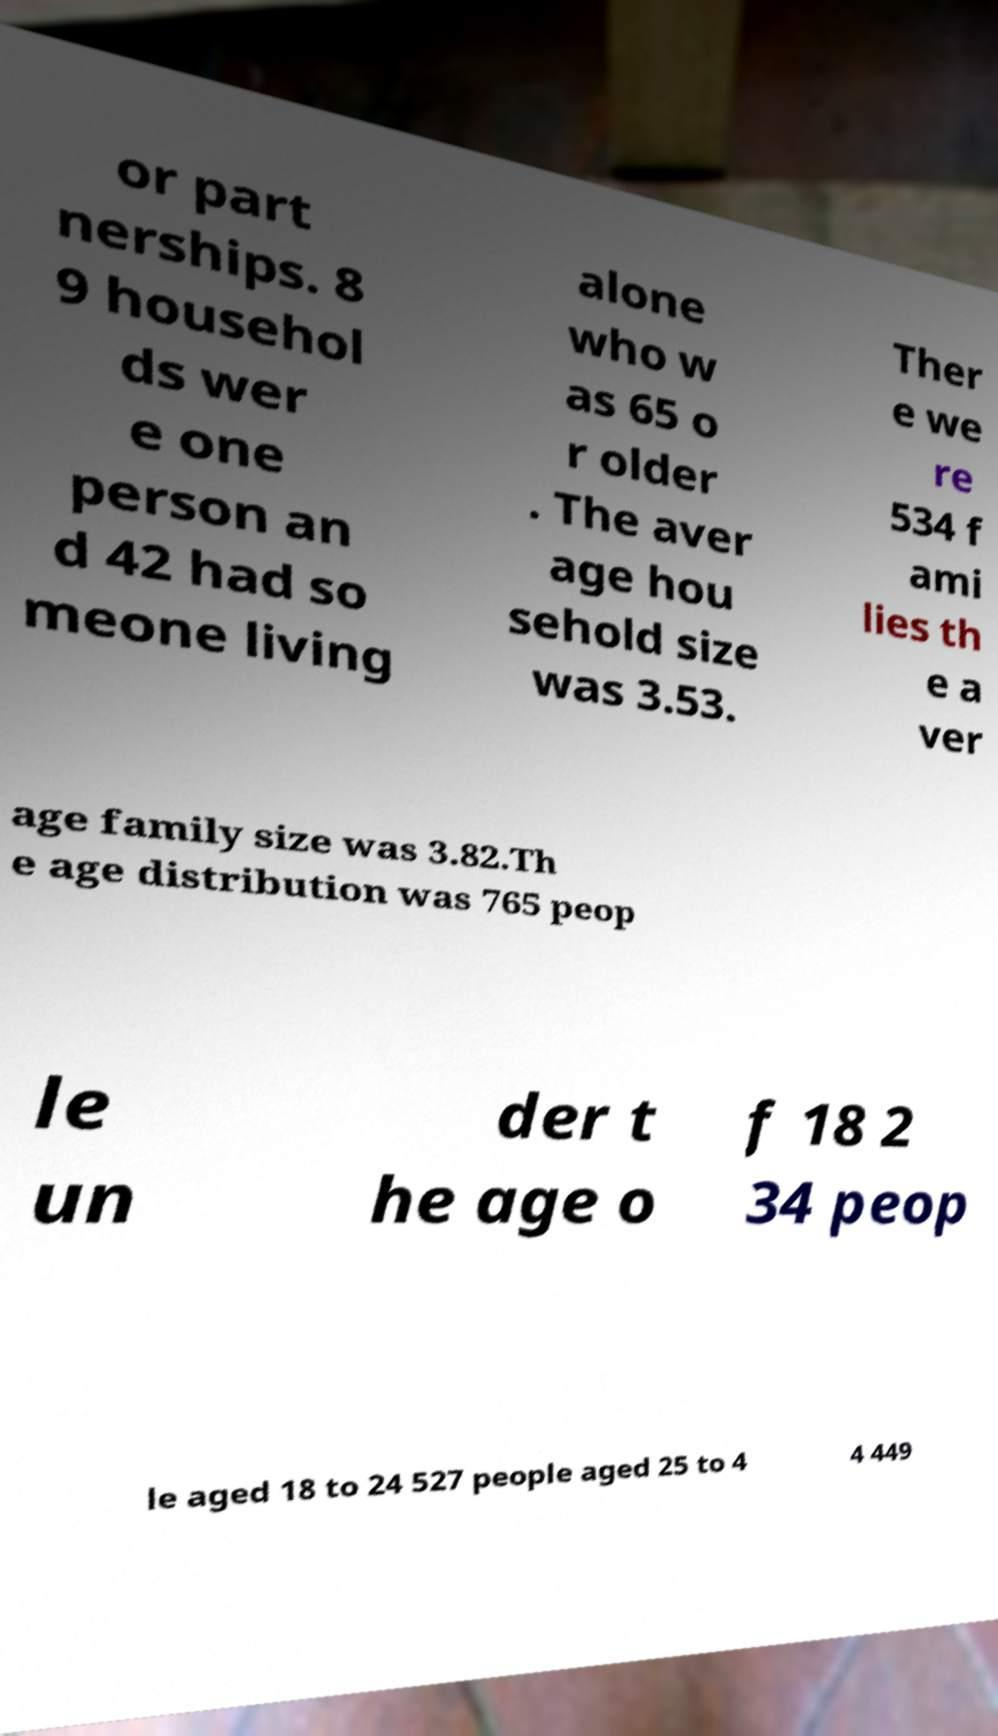I need the written content from this picture converted into text. Can you do that? or part nerships. 8 9 househol ds wer e one person an d 42 had so meone living alone who w as 65 o r older . The aver age hou sehold size was 3.53. Ther e we re 534 f ami lies th e a ver age family size was 3.82.Th e age distribution was 765 peop le un der t he age o f 18 2 34 peop le aged 18 to 24 527 people aged 25 to 4 4 449 